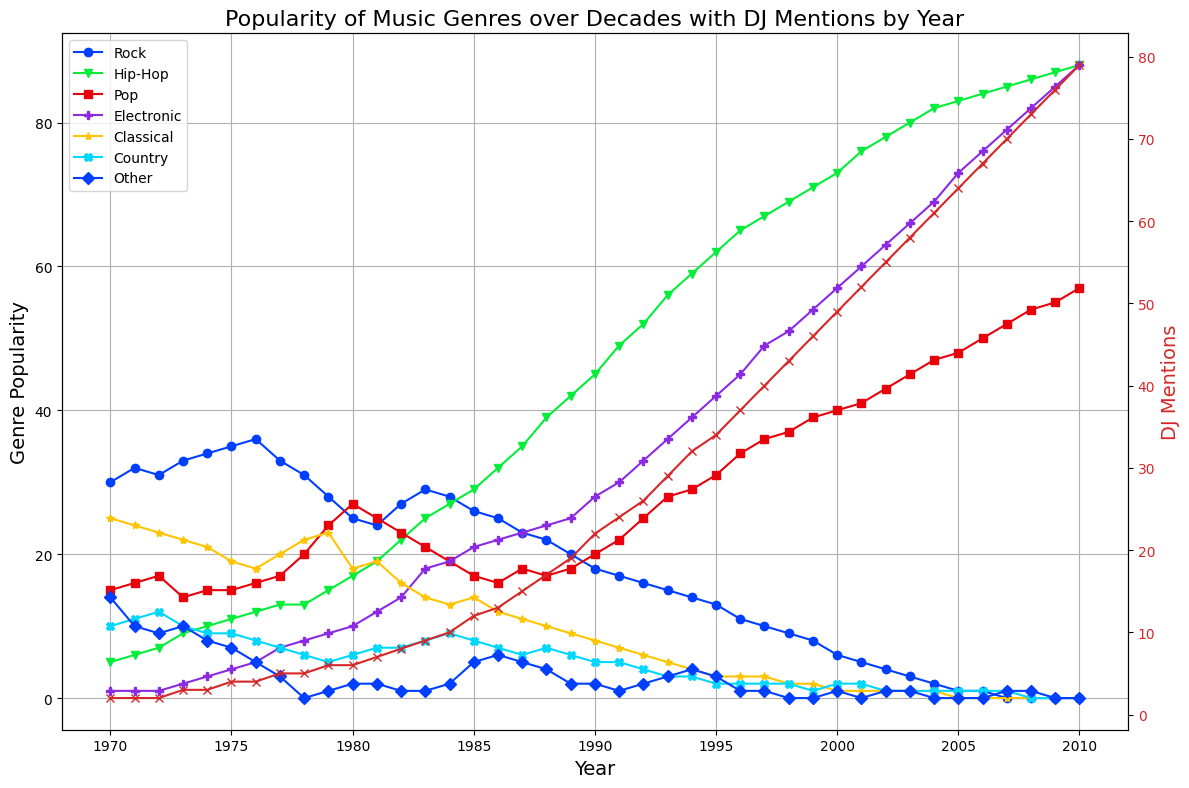What is the overall trend for the popularity of Rock music from 1970 to 2010? To find the overall trend in the popularity of Rock music from 1970 to 2010, one would observe the data points for Rock over these years. The plot shows that the popularity starts high in 1970 and gradually decreases over the decades, reaching 0 in the late 2000s.
Answer: Downward trend Which genre was more popular in 1990, Rock or Hip-Hop? In 1990, the plot shows that the popularity of Rock is 18 and Hip-Hop is 45. Comparing these values, Hip-Hop is more popular than Rock.
Answer: Hip-Hop How did the number of DJ mentions change between 1985 and 1995? By looking at the plot, the number of DJ mentions in 1985 is indicated as approximately 12, and in 1995, it is approximately 34. The change is calculated as 34 - 12.
Answer: Increased by 22 Which genre saw the most significant increase in popularity between 1970 and 2010? Observing the plot from 1970 to 2010, Electronic music shows the most significant increase, starting from 1 in 1970 and reaching 88 in 2010, alongside a significant rise around the late 90s and 2000s.
Answer: Electronic When did DJ mentions first reach or exceed 50? Examining the DJ mentions trend, it's first seen to reach or exceed 50 in the year 2000.
Answer: 2000 Which two genres had the closest popularity values in 2007? Looking at the values for 2007, Pop has a popularity of 52 while Electronic has 79. The closest other pair is Classical with 1 and Country with 1.
Answer: Classical and Country In which decade did Hip-Hop surpass Rock in popularity? From the plot, Rock starts higher than Hip-Hop but Hip-Hop surpasses Rock around the early 1980s, specifically between 1981 and 1982.
Answer: Early 1980s Compare the popularity of Classical music in 1975 and 2005 and state the observed trend. The popularity of Classical music in 1975 is approximately 19, while in 2005 it is 0. This shows a declining trend over the years.
Answer: Declining trend What are the distinctive visual markers used for DJ mentions in the plot? The plot uses a red color with an x marker to represent DJ mentions, distinct from the other genres.
Answer: Red color with an x marker 